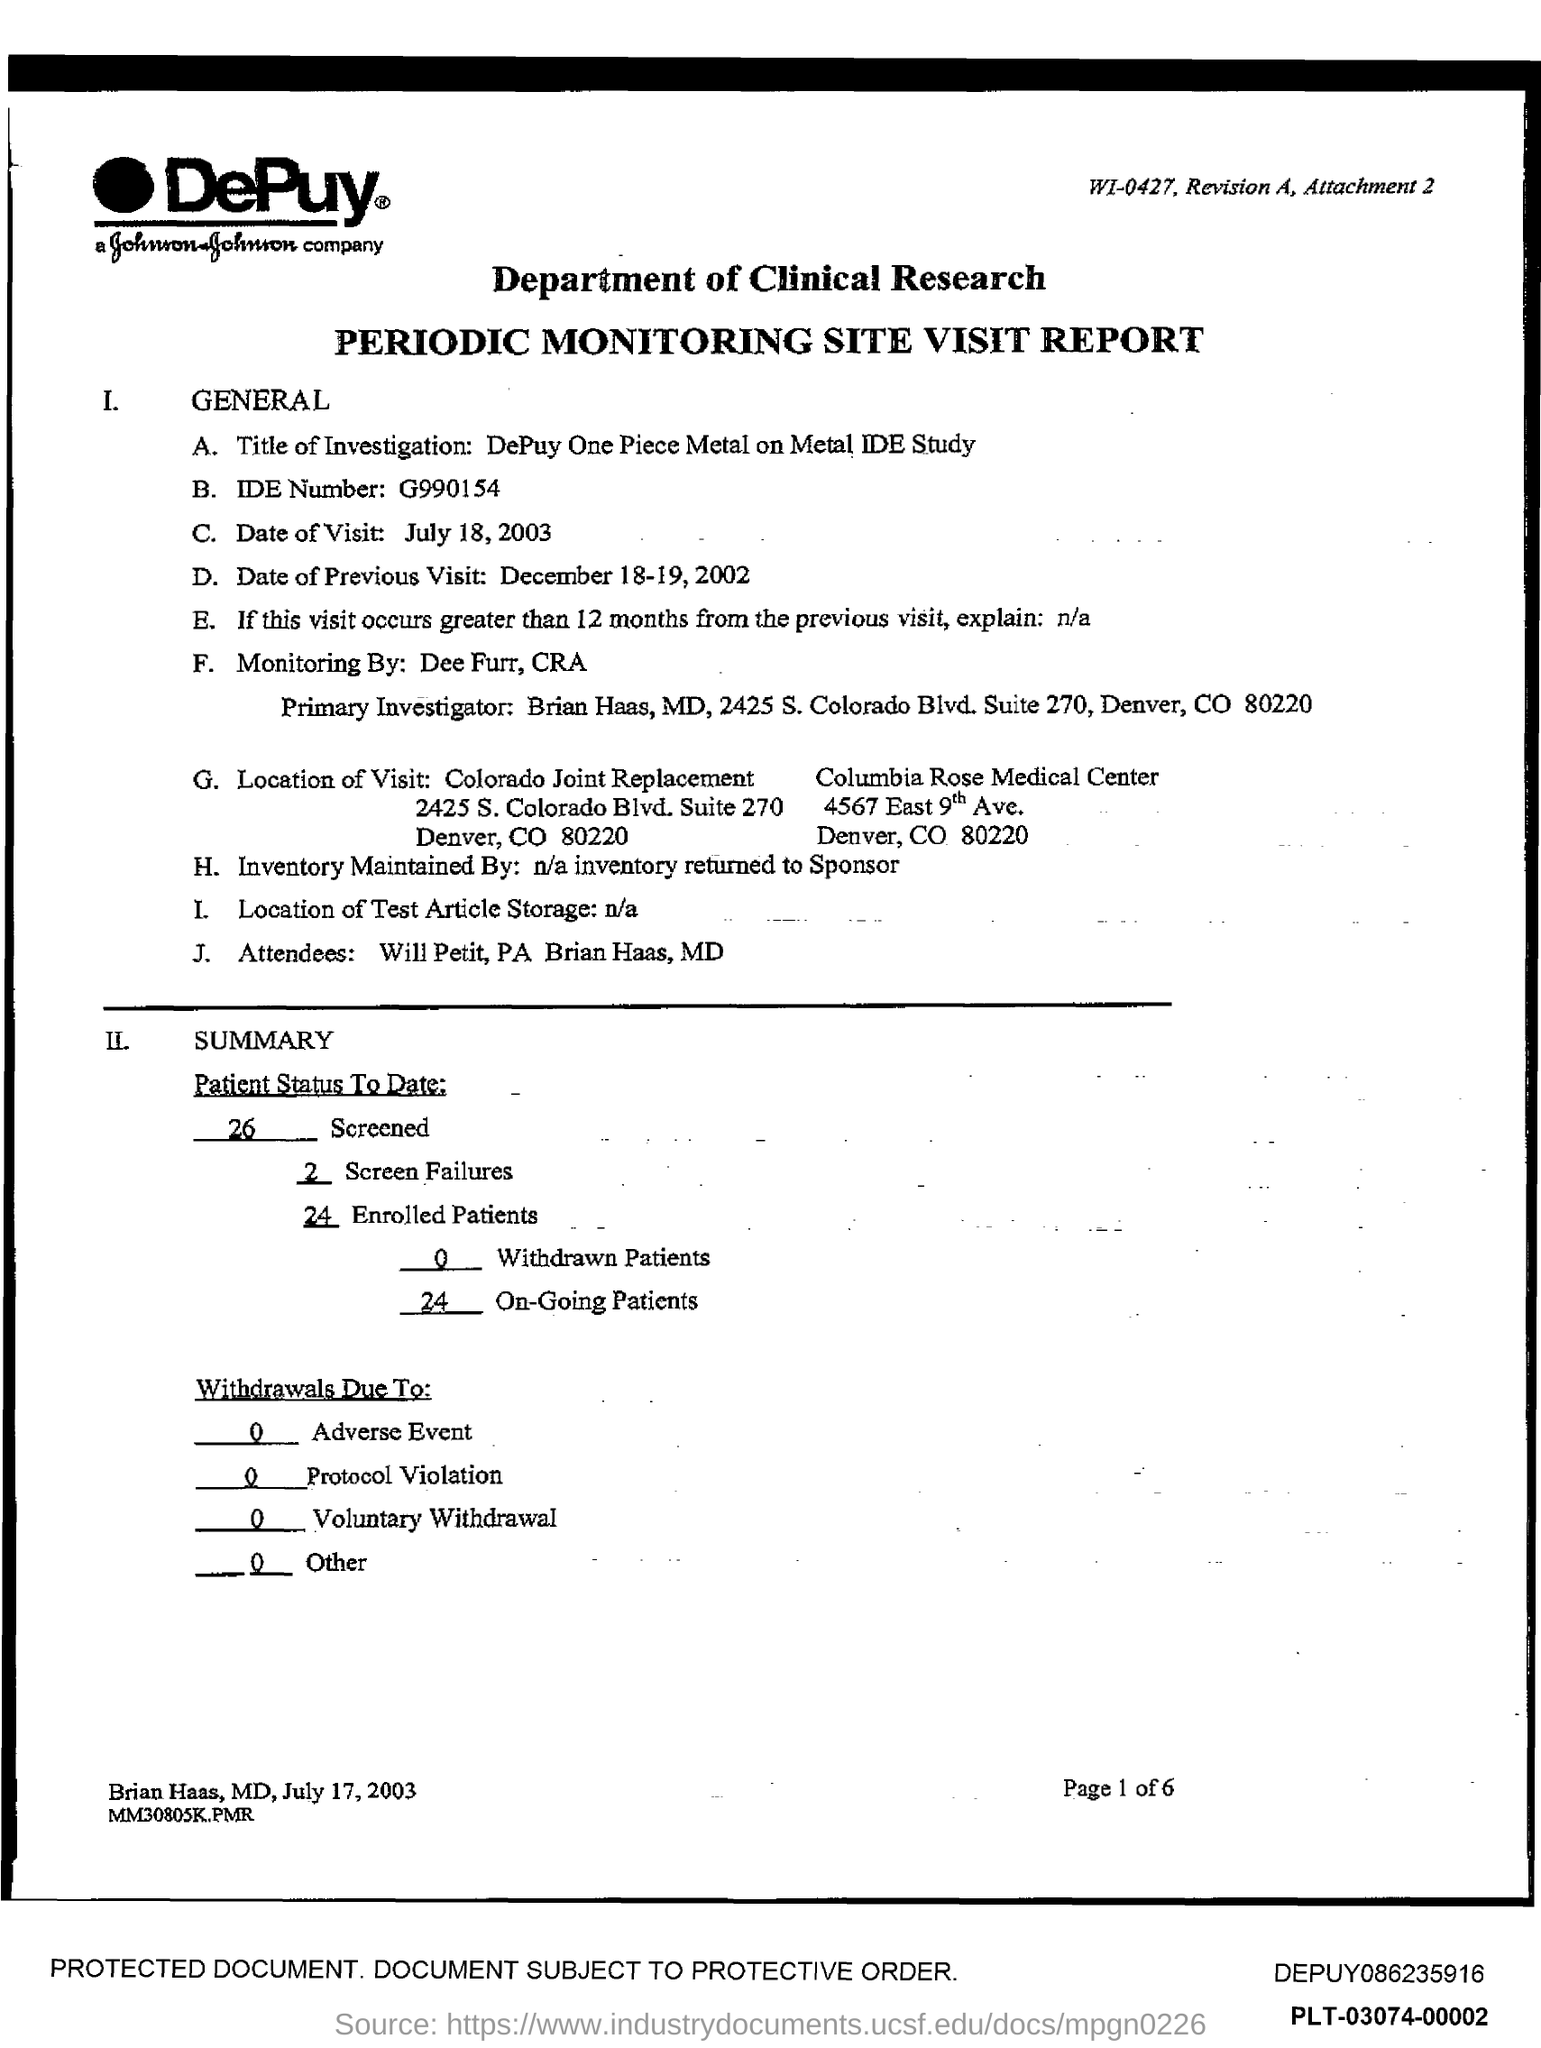Indicate a few pertinent items in this graphic. The date of the visit is July 18, 2003. The IDE number is a unique identifier assigned to a specific IDE. For example, "g990154" is an IDE number. The name of the Primary Investigator is Brian Haas. The previous visit was on December 18-19, 2002. Colorado is where the question "What is the state of Colorado joint replacement?" is located. 